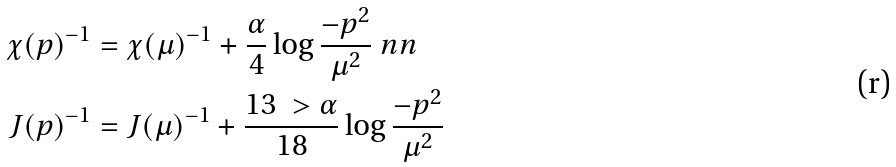<formula> <loc_0><loc_0><loc_500><loc_500>\chi ( p ) ^ { - 1 } & = \chi ( \mu ) ^ { - 1 } + \frac { \alpha } { 4 } \log \frac { - p ^ { 2 } } { \mu ^ { 2 } } \ n n \\ J ( p ) ^ { - 1 } & = J ( \mu ) ^ { - 1 } + \frac { 1 3 \ > \alpha } { 1 8 } \log \frac { - p ^ { 2 } } { \mu ^ { 2 } }</formula> 